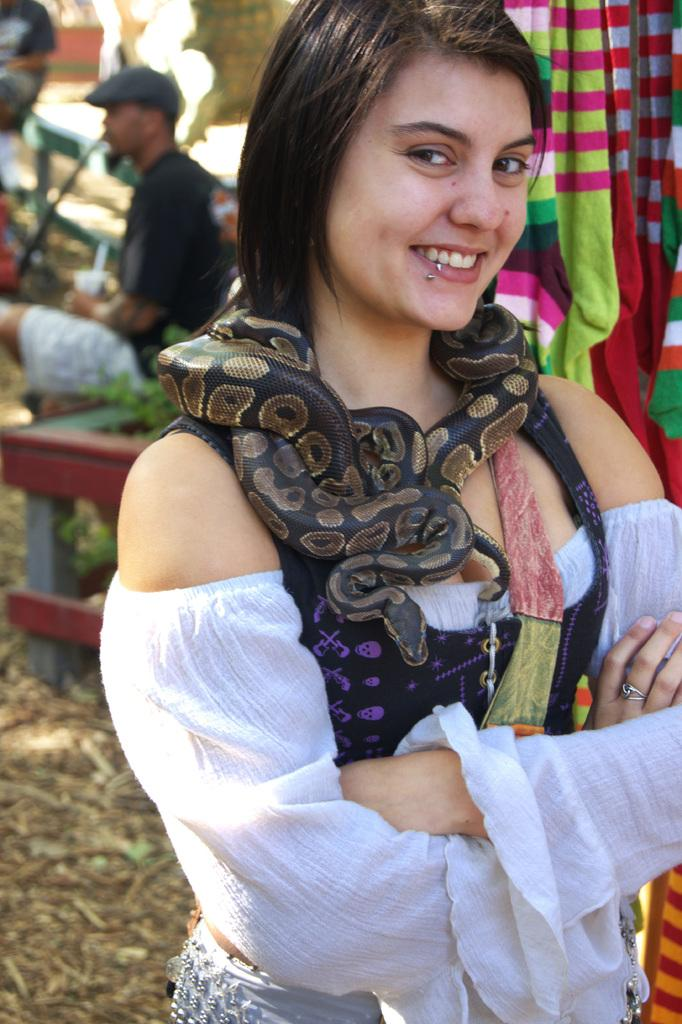What is the woman in the image doing? The woman is standing in the image and smiling. Can you describe the person in the background? There is a person sitting on a bench in the background. What is unusual about the woman in the image? There is a snake around the woman's neck. How many yams are on the woman's head in the image? There are no yams present in the image. Can you see any cobwebs in the image? There is no mention of cobwebs in the provided facts, and none are visible in the image. 